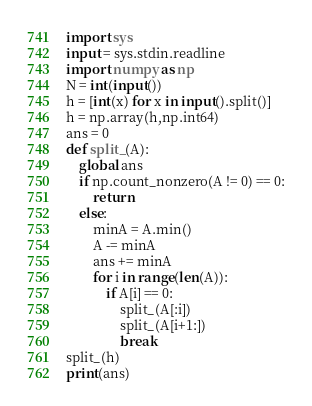Convert code to text. <code><loc_0><loc_0><loc_500><loc_500><_Python_>import sys
input = sys.stdin.readline
import numpy as np
N = int(input())
h = [int(x) for x in input().split()]
h = np.array(h,np.int64)
ans = 0
def split_(A):
    global ans
    if np.count_nonzero(A != 0) == 0:
        return
    else:
        minA = A.min()
        A -= minA
        ans += minA
        for i in range(len(A)):
            if A[i] == 0:
                split_(A[:i])
                split_(A[i+1:])
                break
split_(h)
print(ans)</code> 